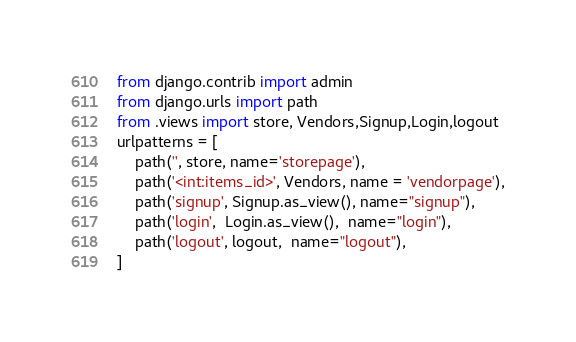Convert code to text. <code><loc_0><loc_0><loc_500><loc_500><_Python_>from django.contrib import admin
from django.urls import path
from .views import store, Vendors,Signup,Login,logout
urlpatterns = [
    path('', store, name='storepage'),
    path('<int:items_id>', Vendors, name = 'vendorpage'),
    path('signup', Signup.as_view(), name="signup"),
    path('login',  Login.as_view(),  name="login"),
    path('logout', logout,  name="logout"),
]</code> 